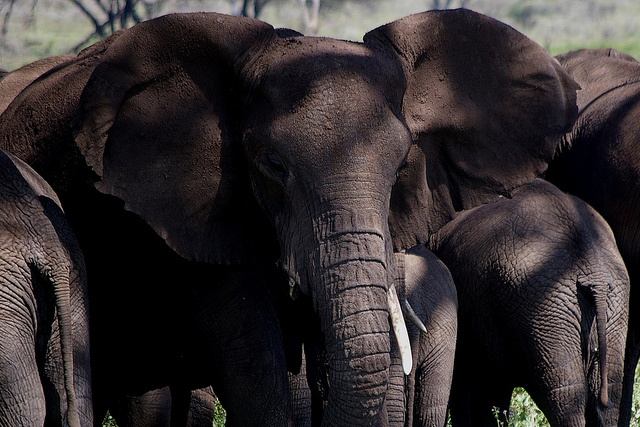Describe the objects in this image and their specific colors. I can see elephant in black and gray tones, elephant in gray, black, and darkgray tones, elephant in gray, black, and darkgray tones, elephant in gray and black tones, and elephant in gray, black, and darkgray tones in this image. 